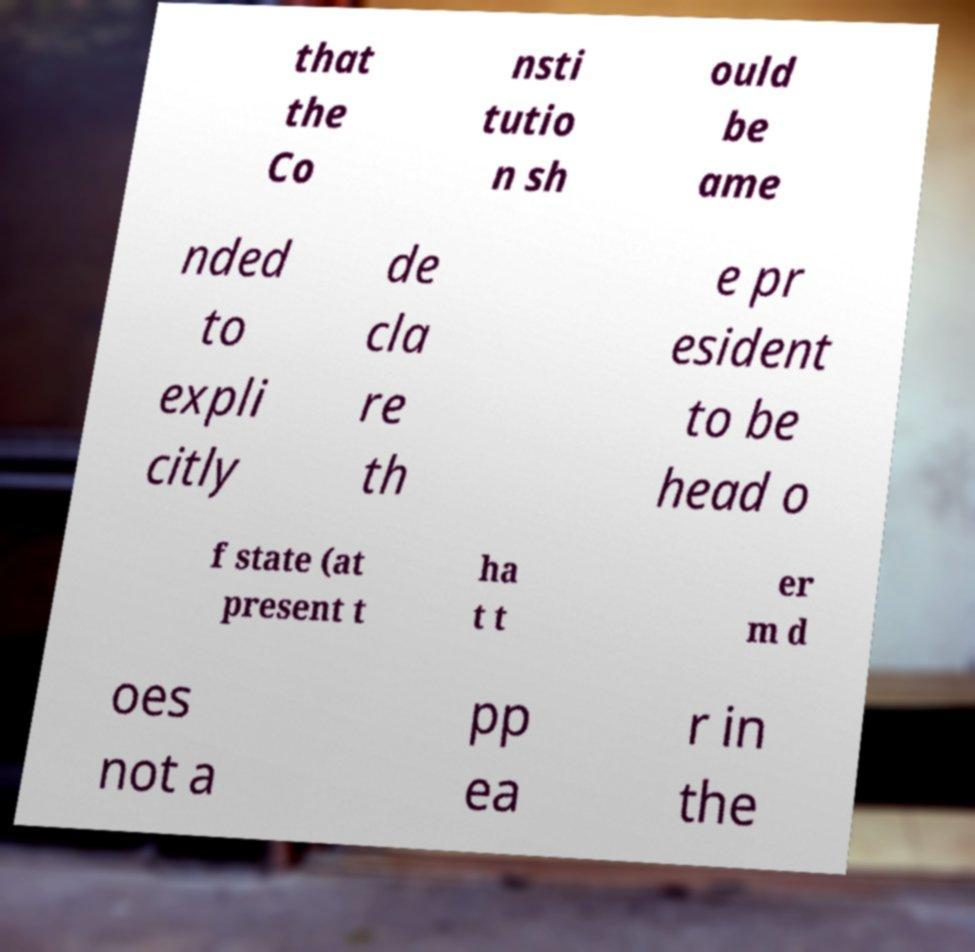For documentation purposes, I need the text within this image transcribed. Could you provide that? that the Co nsti tutio n sh ould be ame nded to expli citly de cla re th e pr esident to be head o f state (at present t ha t t er m d oes not a pp ea r in the 